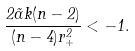Convert formula to latex. <formula><loc_0><loc_0><loc_500><loc_500>\frac { 2 \tilde { \alpha } k ( n - 2 ) } { ( n - 4 ) r _ { + } ^ { 2 } } < - 1 .</formula> 